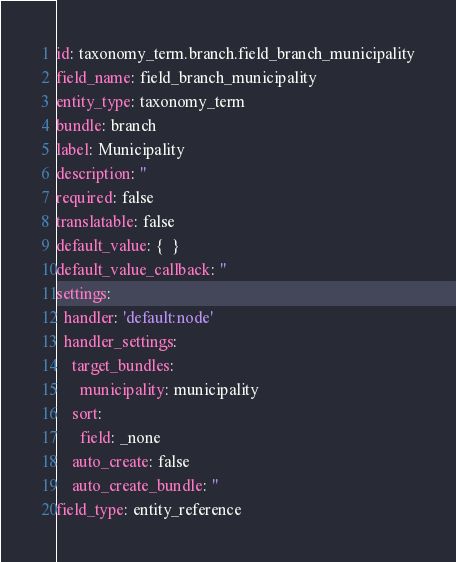<code> <loc_0><loc_0><loc_500><loc_500><_YAML_>id: taxonomy_term.branch.field_branch_municipality
field_name: field_branch_municipality
entity_type: taxonomy_term
bundle: branch
label: Municipality
description: ''
required: false
translatable: false
default_value: {  }
default_value_callback: ''
settings:
  handler: 'default:node'
  handler_settings:
    target_bundles:
      municipality: municipality
    sort:
      field: _none
    auto_create: false
    auto_create_bundle: ''
field_type: entity_reference
</code> 